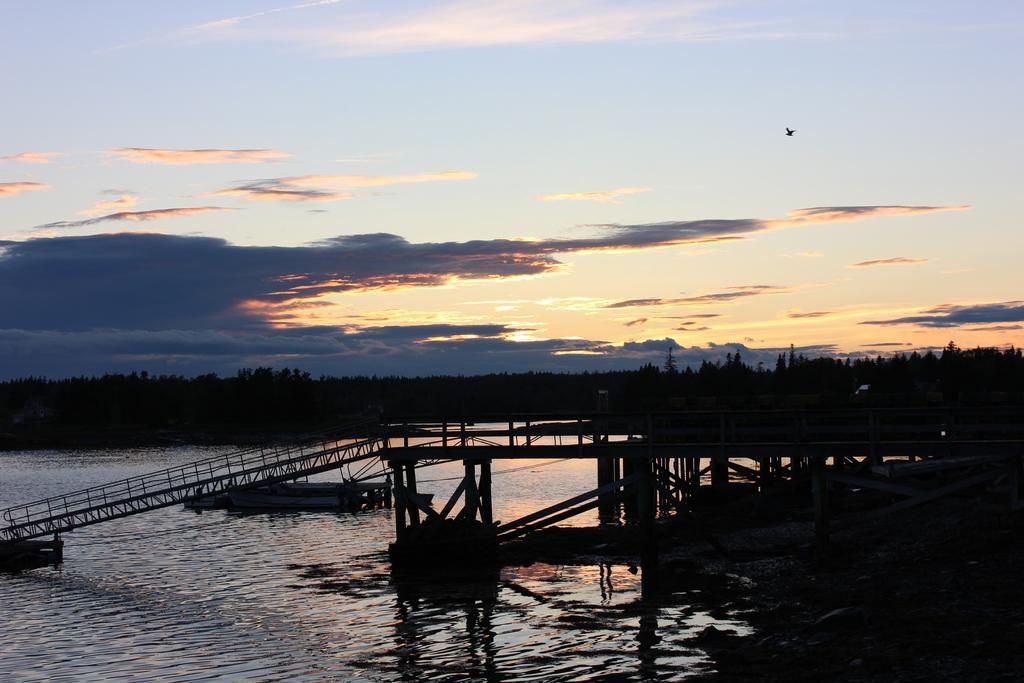Can you describe this image briefly? This image consists of a bridge made up of wood. To the left, there are steps. At the bottom, there is water. In the background, there are trees and plants. To the top, there are clouds in the sky. 